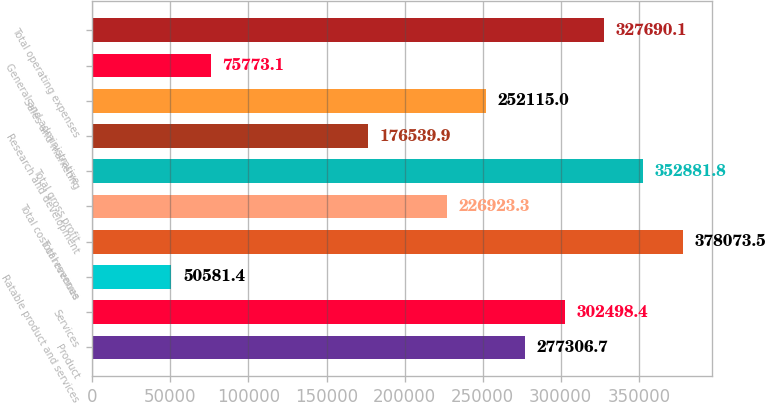<chart> <loc_0><loc_0><loc_500><loc_500><bar_chart><fcel>Product<fcel>Services<fcel>Ratable product and services<fcel>Total revenue<fcel>Total cost of revenues<fcel>Total gross profit<fcel>Research and development<fcel>Sales and marketing<fcel>General and administrative<fcel>Total operating expenses<nl><fcel>277307<fcel>302498<fcel>50581.4<fcel>378074<fcel>226923<fcel>352882<fcel>176540<fcel>252115<fcel>75773.1<fcel>327690<nl></chart> 